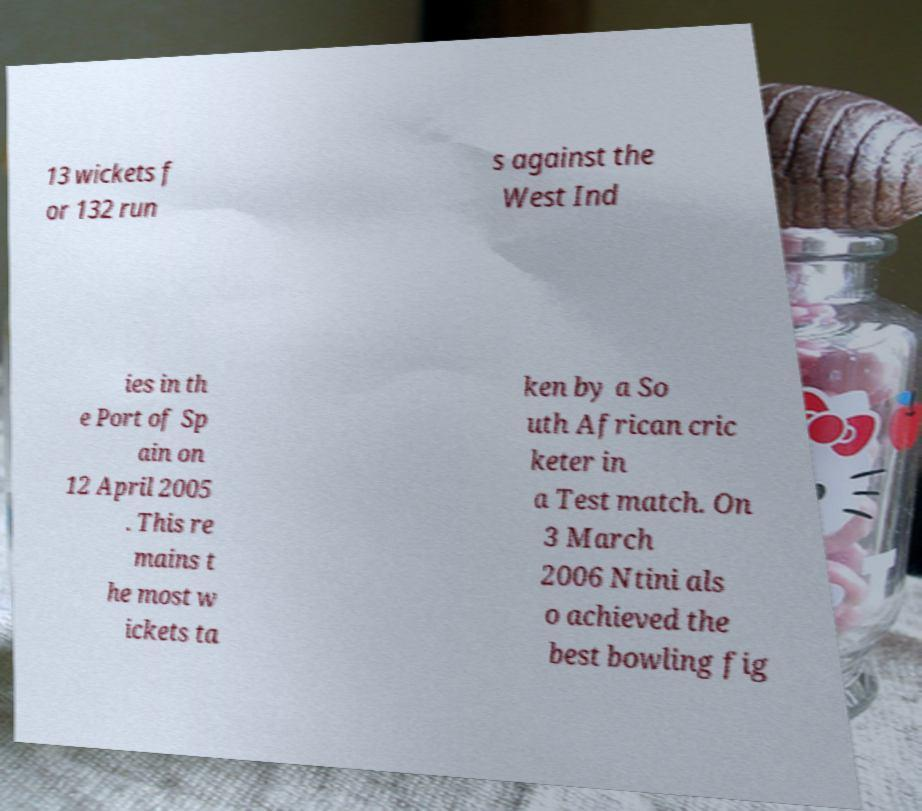Please identify and transcribe the text found in this image. 13 wickets f or 132 run s against the West Ind ies in th e Port of Sp ain on 12 April 2005 . This re mains t he most w ickets ta ken by a So uth African cric keter in a Test match. On 3 March 2006 Ntini als o achieved the best bowling fig 